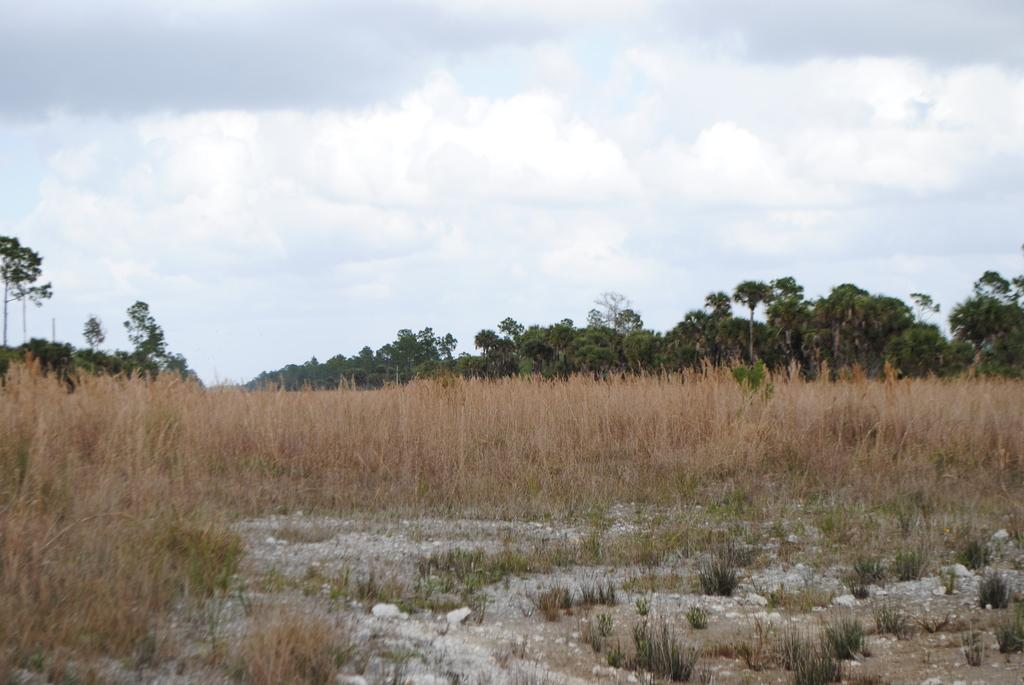What type of vegetation is present in the image? There is dry grass in the image. What can be seen in the background of the image? There are trees and the sky visible in the background of the image. What is the condition of the sky in the image? The sky is visible in the background of the image, and there are clouds present. What type of letters can be seen being written in the image? There are no letters or writing present in the image. What type of love is being expressed in the image? There is no expression of love in the image; it features dry grass, trees, and the sky. 